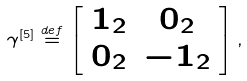<formula> <loc_0><loc_0><loc_500><loc_500>\gamma ^ { \left [ 5 \right ] } \stackrel { d e f } { = } \left [ \begin{array} { c c } 1 _ { 2 } & 0 _ { 2 } \\ 0 _ { 2 } & - 1 _ { 2 } \end{array} \right ] ,</formula> 